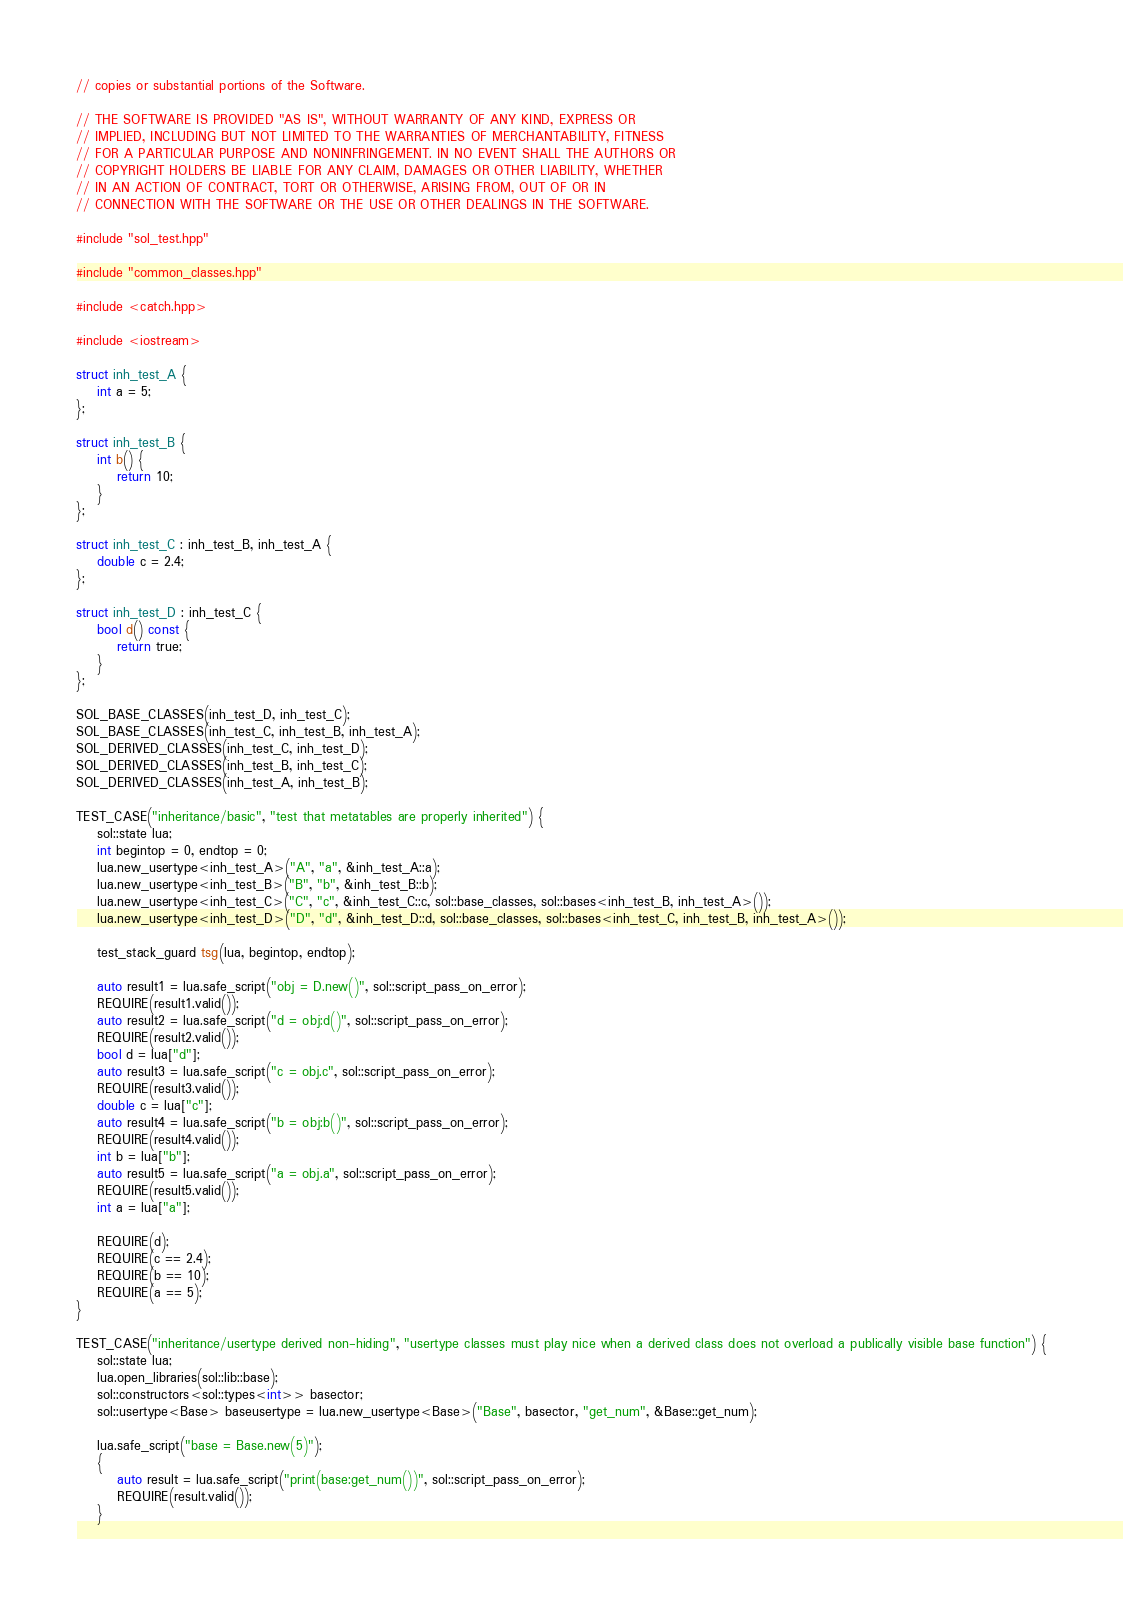Convert code to text. <code><loc_0><loc_0><loc_500><loc_500><_C++_>// copies or substantial portions of the Software.

// THE SOFTWARE IS PROVIDED "AS IS", WITHOUT WARRANTY OF ANY KIND, EXPRESS OR
// IMPLIED, INCLUDING BUT NOT LIMITED TO THE WARRANTIES OF MERCHANTABILITY, FITNESS
// FOR A PARTICULAR PURPOSE AND NONINFRINGEMENT. IN NO EVENT SHALL THE AUTHORS OR
// COPYRIGHT HOLDERS BE LIABLE FOR ANY CLAIM, DAMAGES OR OTHER LIABILITY, WHETHER
// IN AN ACTION OF CONTRACT, TORT OR OTHERWISE, ARISING FROM, OUT OF OR IN
// CONNECTION WITH THE SOFTWARE OR THE USE OR OTHER DEALINGS IN THE SOFTWARE.

#include "sol_test.hpp"

#include "common_classes.hpp"

#include <catch.hpp>

#include <iostream>

struct inh_test_A {
	int a = 5;
};

struct inh_test_B {
	int b() {
		return 10;
	}
};

struct inh_test_C : inh_test_B, inh_test_A {
	double c = 2.4;
};

struct inh_test_D : inh_test_C {
	bool d() const {
		return true;
	}
};

SOL_BASE_CLASSES(inh_test_D, inh_test_C);
SOL_BASE_CLASSES(inh_test_C, inh_test_B, inh_test_A);
SOL_DERIVED_CLASSES(inh_test_C, inh_test_D);
SOL_DERIVED_CLASSES(inh_test_B, inh_test_C);
SOL_DERIVED_CLASSES(inh_test_A, inh_test_B);

TEST_CASE("inheritance/basic", "test that metatables are properly inherited") {
	sol::state lua;
	int begintop = 0, endtop = 0;
	lua.new_usertype<inh_test_A>("A", "a", &inh_test_A::a);
	lua.new_usertype<inh_test_B>("B", "b", &inh_test_B::b);
	lua.new_usertype<inh_test_C>("C", "c", &inh_test_C::c, sol::base_classes, sol::bases<inh_test_B, inh_test_A>());
	lua.new_usertype<inh_test_D>("D", "d", &inh_test_D::d, sol::base_classes, sol::bases<inh_test_C, inh_test_B, inh_test_A>());

	test_stack_guard tsg(lua, begintop, endtop);

	auto result1 = lua.safe_script("obj = D.new()", sol::script_pass_on_error);
	REQUIRE(result1.valid());
	auto result2 = lua.safe_script("d = obj:d()", sol::script_pass_on_error);
	REQUIRE(result2.valid());
	bool d = lua["d"];
	auto result3 = lua.safe_script("c = obj.c", sol::script_pass_on_error);
	REQUIRE(result3.valid());
	double c = lua["c"];
	auto result4 = lua.safe_script("b = obj:b()", sol::script_pass_on_error);
	REQUIRE(result4.valid());
	int b = lua["b"];
	auto result5 = lua.safe_script("a = obj.a", sol::script_pass_on_error);
	REQUIRE(result5.valid());
	int a = lua["a"];

	REQUIRE(d);
	REQUIRE(c == 2.4);
	REQUIRE(b == 10);
	REQUIRE(a == 5);
}

TEST_CASE("inheritance/usertype derived non-hiding", "usertype classes must play nice when a derived class does not overload a publically visible base function") {
	sol::state lua;
	lua.open_libraries(sol::lib::base);
	sol::constructors<sol::types<int>> basector;
	sol::usertype<Base> baseusertype = lua.new_usertype<Base>("Base", basector, "get_num", &Base::get_num);

	lua.safe_script("base = Base.new(5)");
	{
		auto result = lua.safe_script("print(base:get_num())", sol::script_pass_on_error);
		REQUIRE(result.valid());
	}
</code> 